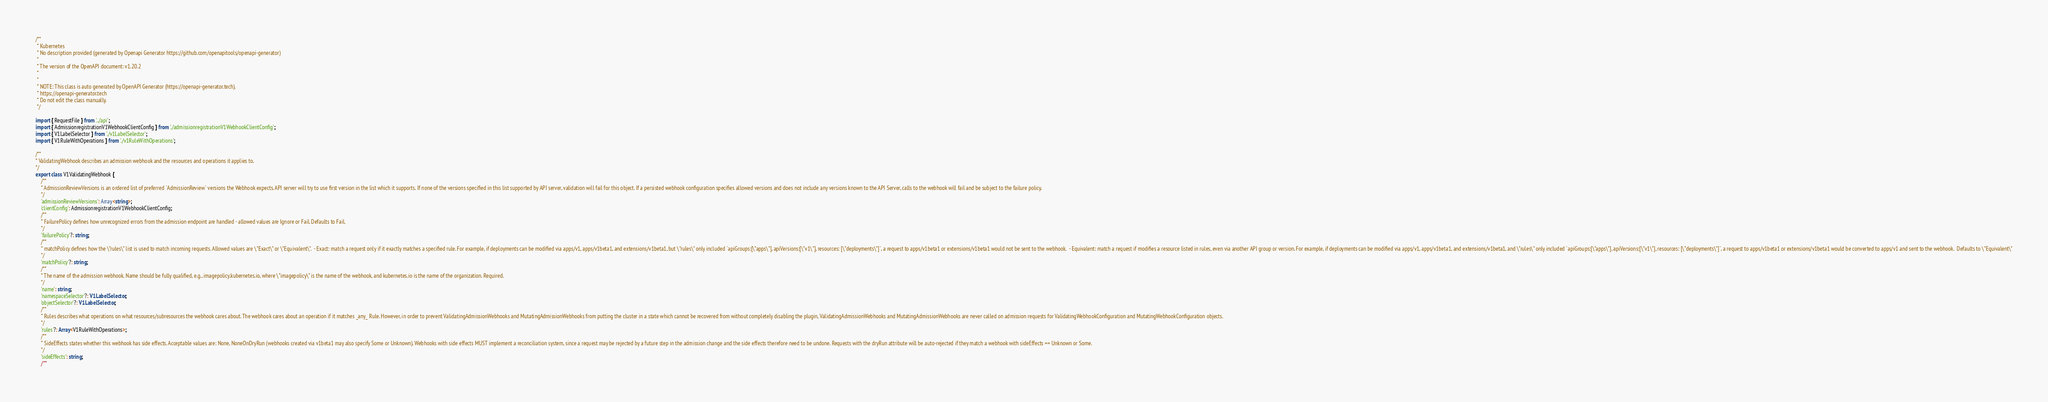<code> <loc_0><loc_0><loc_500><loc_500><_TypeScript_>/**
 * Kubernetes
 * No description provided (generated by Openapi Generator https://github.com/openapitools/openapi-generator)
 *
 * The version of the OpenAPI document: v1.20.2
 * 
 *
 * NOTE: This class is auto generated by OpenAPI Generator (https://openapi-generator.tech).
 * https://openapi-generator.tech
 * Do not edit the class manually.
 */

import { RequestFile } from '../api';
import { AdmissionregistrationV1WebhookClientConfig } from './admissionregistrationV1WebhookClientConfig';
import { V1LabelSelector } from './v1LabelSelector';
import { V1RuleWithOperations } from './v1RuleWithOperations';

/**
* ValidatingWebhook describes an admission webhook and the resources and operations it applies to.
*/
export class V1ValidatingWebhook {
    /**
    * AdmissionReviewVersions is an ordered list of preferred `AdmissionReview` versions the Webhook expects. API server will try to use first version in the list which it supports. If none of the versions specified in this list supported by API server, validation will fail for this object. If a persisted webhook configuration specifies allowed versions and does not include any versions known to the API Server, calls to the webhook will fail and be subject to the failure policy.
    */
    'admissionReviewVersions': Array<string>;
    'clientConfig': AdmissionregistrationV1WebhookClientConfig;
    /**
    * FailurePolicy defines how unrecognized errors from the admission endpoint are handled - allowed values are Ignore or Fail. Defaults to Fail.
    */
    'failurePolicy'?: string;
    /**
    * matchPolicy defines how the \"rules\" list is used to match incoming requests. Allowed values are \"Exact\" or \"Equivalent\".  - Exact: match a request only if it exactly matches a specified rule. For example, if deployments can be modified via apps/v1, apps/v1beta1, and extensions/v1beta1, but \"rules\" only included `apiGroups:[\"apps\"], apiVersions:[\"v1\"], resources: [\"deployments\"]`, a request to apps/v1beta1 or extensions/v1beta1 would not be sent to the webhook.  - Equivalent: match a request if modifies a resource listed in rules, even via another API group or version. For example, if deployments can be modified via apps/v1, apps/v1beta1, and extensions/v1beta1, and \"rules\" only included `apiGroups:[\"apps\"], apiVersions:[\"v1\"], resources: [\"deployments\"]`, a request to apps/v1beta1 or extensions/v1beta1 would be converted to apps/v1 and sent to the webhook.  Defaults to \"Equivalent\"
    */
    'matchPolicy'?: string;
    /**
    * The name of the admission webhook. Name should be fully qualified, e.g., imagepolicy.kubernetes.io, where \"imagepolicy\" is the name of the webhook, and kubernetes.io is the name of the organization. Required.
    */
    'name': string;
    'namespaceSelector'?: V1LabelSelector;
    'objectSelector'?: V1LabelSelector;
    /**
    * Rules describes what operations on what resources/subresources the webhook cares about. The webhook cares about an operation if it matches _any_ Rule. However, in order to prevent ValidatingAdmissionWebhooks and MutatingAdmissionWebhooks from putting the cluster in a state which cannot be recovered from without completely disabling the plugin, ValidatingAdmissionWebhooks and MutatingAdmissionWebhooks are never called on admission requests for ValidatingWebhookConfiguration and MutatingWebhookConfiguration objects.
    */
    'rules'?: Array<V1RuleWithOperations>;
    /**
    * SideEffects states whether this webhook has side effects. Acceptable values are: None, NoneOnDryRun (webhooks created via v1beta1 may also specify Some or Unknown). Webhooks with side effects MUST implement a reconciliation system, since a request may be rejected by a future step in the admission change and the side effects therefore need to be undone. Requests with the dryRun attribute will be auto-rejected if they match a webhook with sideEffects == Unknown or Some.
    */
    'sideEffects': string;
    /**</code> 